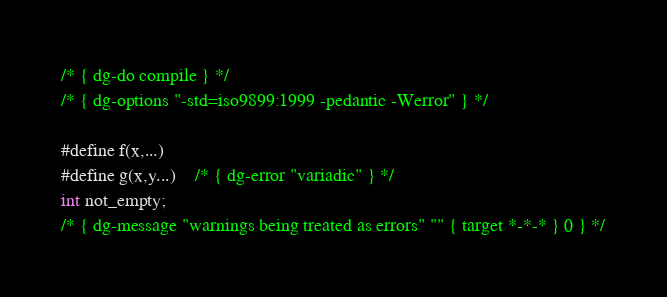<code> <loc_0><loc_0><loc_500><loc_500><_C_>/* { dg-do compile } */
/* { dg-options "-std=iso9899:1999 -pedantic -Werror" } */

#define f(x,...)
#define g(x,y...)	/* { dg-error "variadic" } */
int not_empty;
/* { dg-message "warnings being treated as errors" "" { target *-*-* } 0 } */
</code> 